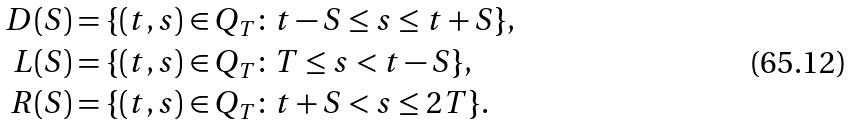<formula> <loc_0><loc_0><loc_500><loc_500>D ( S ) & = \{ ( t , s ) \in Q _ { T } \colon t - S \leq s \leq t + S \} , \\ L ( S ) & = \{ ( t , s ) \in Q _ { T } \colon T \leq s < t - S \} , \\ R ( S ) & = \{ ( t , s ) \in Q _ { T } \colon t + S < s \leq 2 T \} .</formula> 